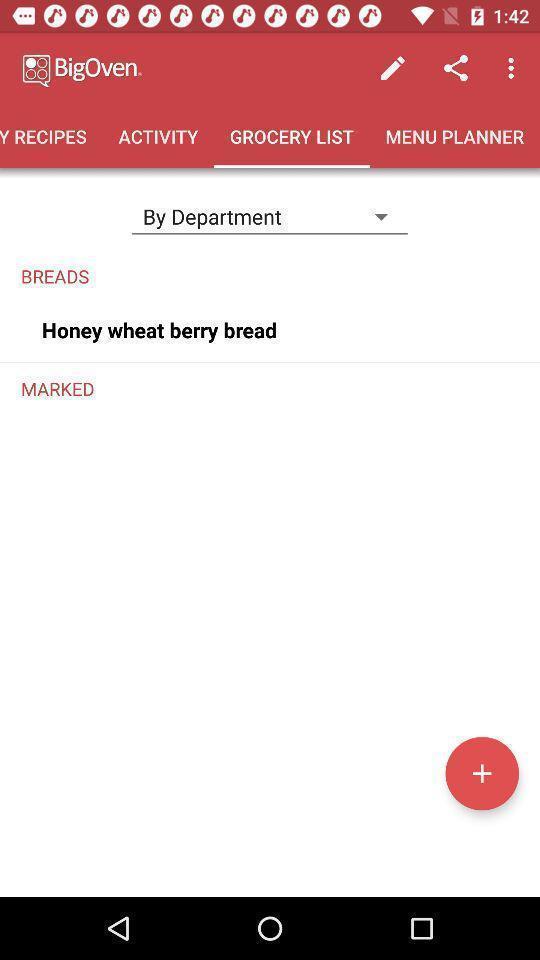What is the overall content of this screenshot? Window displaying an cooking app. 